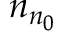Convert formula to latex. <formula><loc_0><loc_0><loc_500><loc_500>n _ { n _ { 0 } }</formula> 